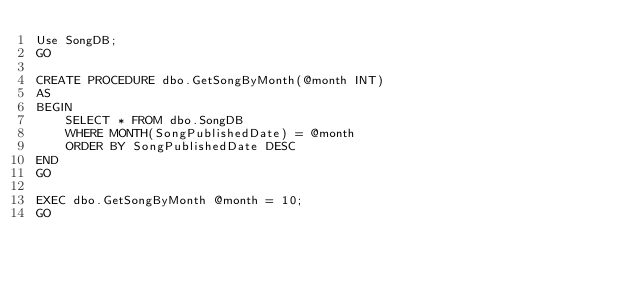<code> <loc_0><loc_0><loc_500><loc_500><_SQL_>Use SongDB;
GO

CREATE PROCEDURE dbo.GetSongByMonth(@month INT)
AS
BEGIN
	SELECT * FROM dbo.SongDB
	WHERE MONTH(SongPublishedDate) = @month
	ORDER BY SongPublishedDate DESC
END
GO

EXEC dbo.GetSongByMonth @month = 10;
GO</code> 